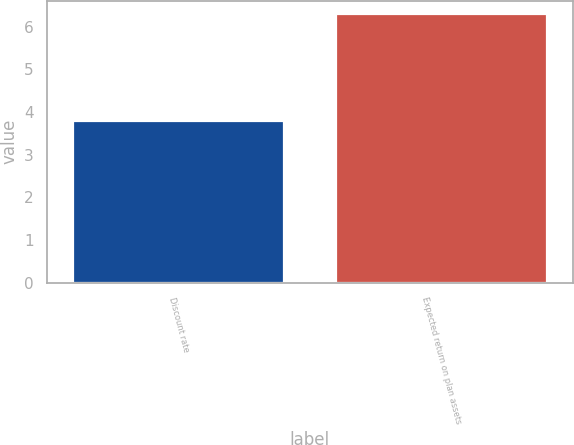Convert chart to OTSL. <chart><loc_0><loc_0><loc_500><loc_500><bar_chart><fcel>Discount rate<fcel>Expected return on plan assets<nl><fcel>3.8<fcel>6.3<nl></chart> 